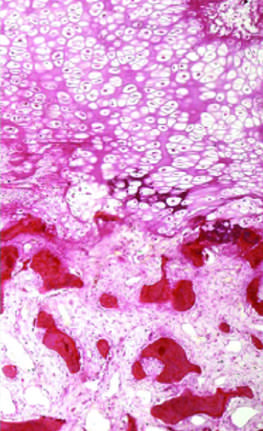s the palisade of cartilage absent?
Answer the question using a single word or phrase. Yes 